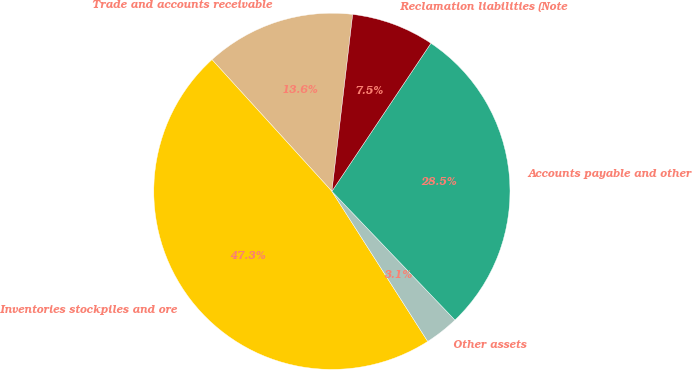Convert chart. <chart><loc_0><loc_0><loc_500><loc_500><pie_chart><fcel>Trade and accounts receivable<fcel>Inventories stockpiles and ore<fcel>Other assets<fcel>Accounts payable and other<fcel>Reclamation liabilities (Note<nl><fcel>13.62%<fcel>47.29%<fcel>3.1%<fcel>28.48%<fcel>7.52%<nl></chart> 